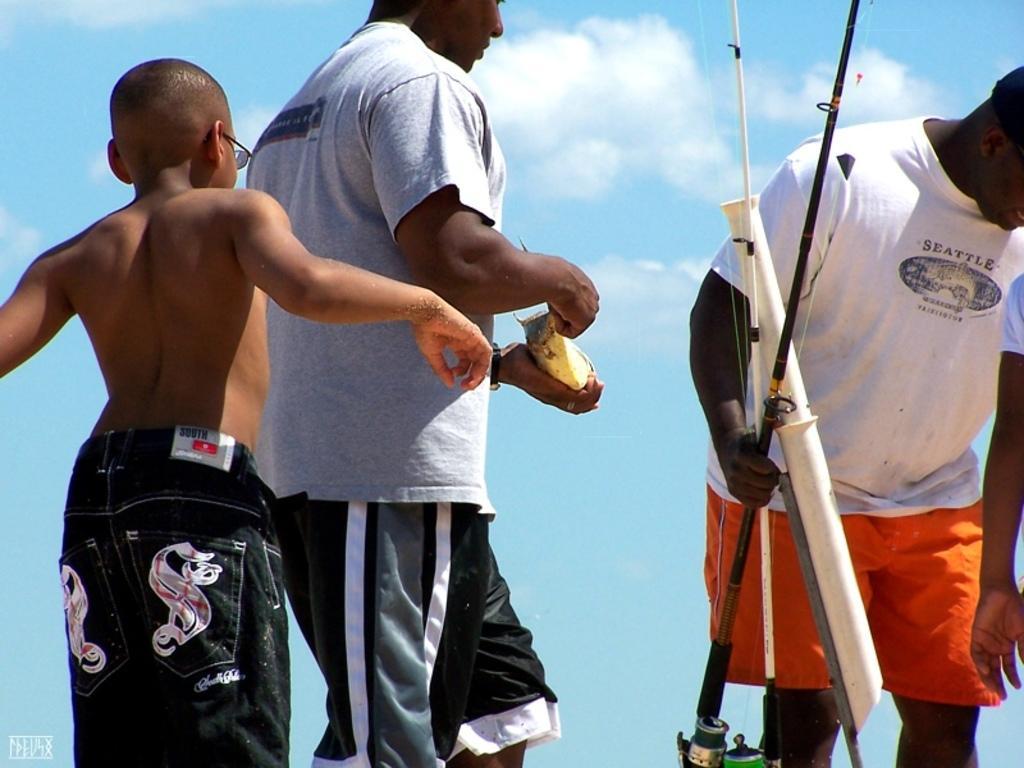How would you summarize this image in a sentence or two? In this picture we can see three persons, a man on the right side is holding something, we can see the sky in the background. 